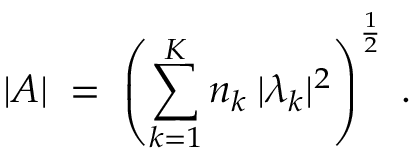<formula> <loc_0><loc_0><loc_500><loc_500>| A | \, = \, \left ( \sum _ { k = 1 } ^ { K } n _ { k } \, | \lambda _ { k } | ^ { 2 } \right ) ^ { \frac { 1 } { 2 } } \, .</formula> 